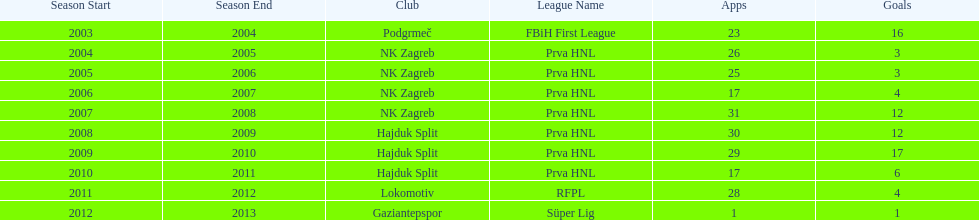After scoring against bulgaria in zenica, ibricic also scored against this team in a 7-0 victory in zenica less then a month after the friendly match against bulgaria. Estonia. 